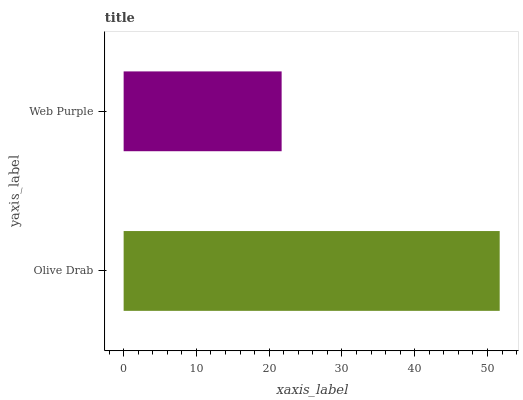Is Web Purple the minimum?
Answer yes or no. Yes. Is Olive Drab the maximum?
Answer yes or no. Yes. Is Web Purple the maximum?
Answer yes or no. No. Is Olive Drab greater than Web Purple?
Answer yes or no. Yes. Is Web Purple less than Olive Drab?
Answer yes or no. Yes. Is Web Purple greater than Olive Drab?
Answer yes or no. No. Is Olive Drab less than Web Purple?
Answer yes or no. No. Is Olive Drab the high median?
Answer yes or no. Yes. Is Web Purple the low median?
Answer yes or no. Yes. Is Web Purple the high median?
Answer yes or no. No. Is Olive Drab the low median?
Answer yes or no. No. 